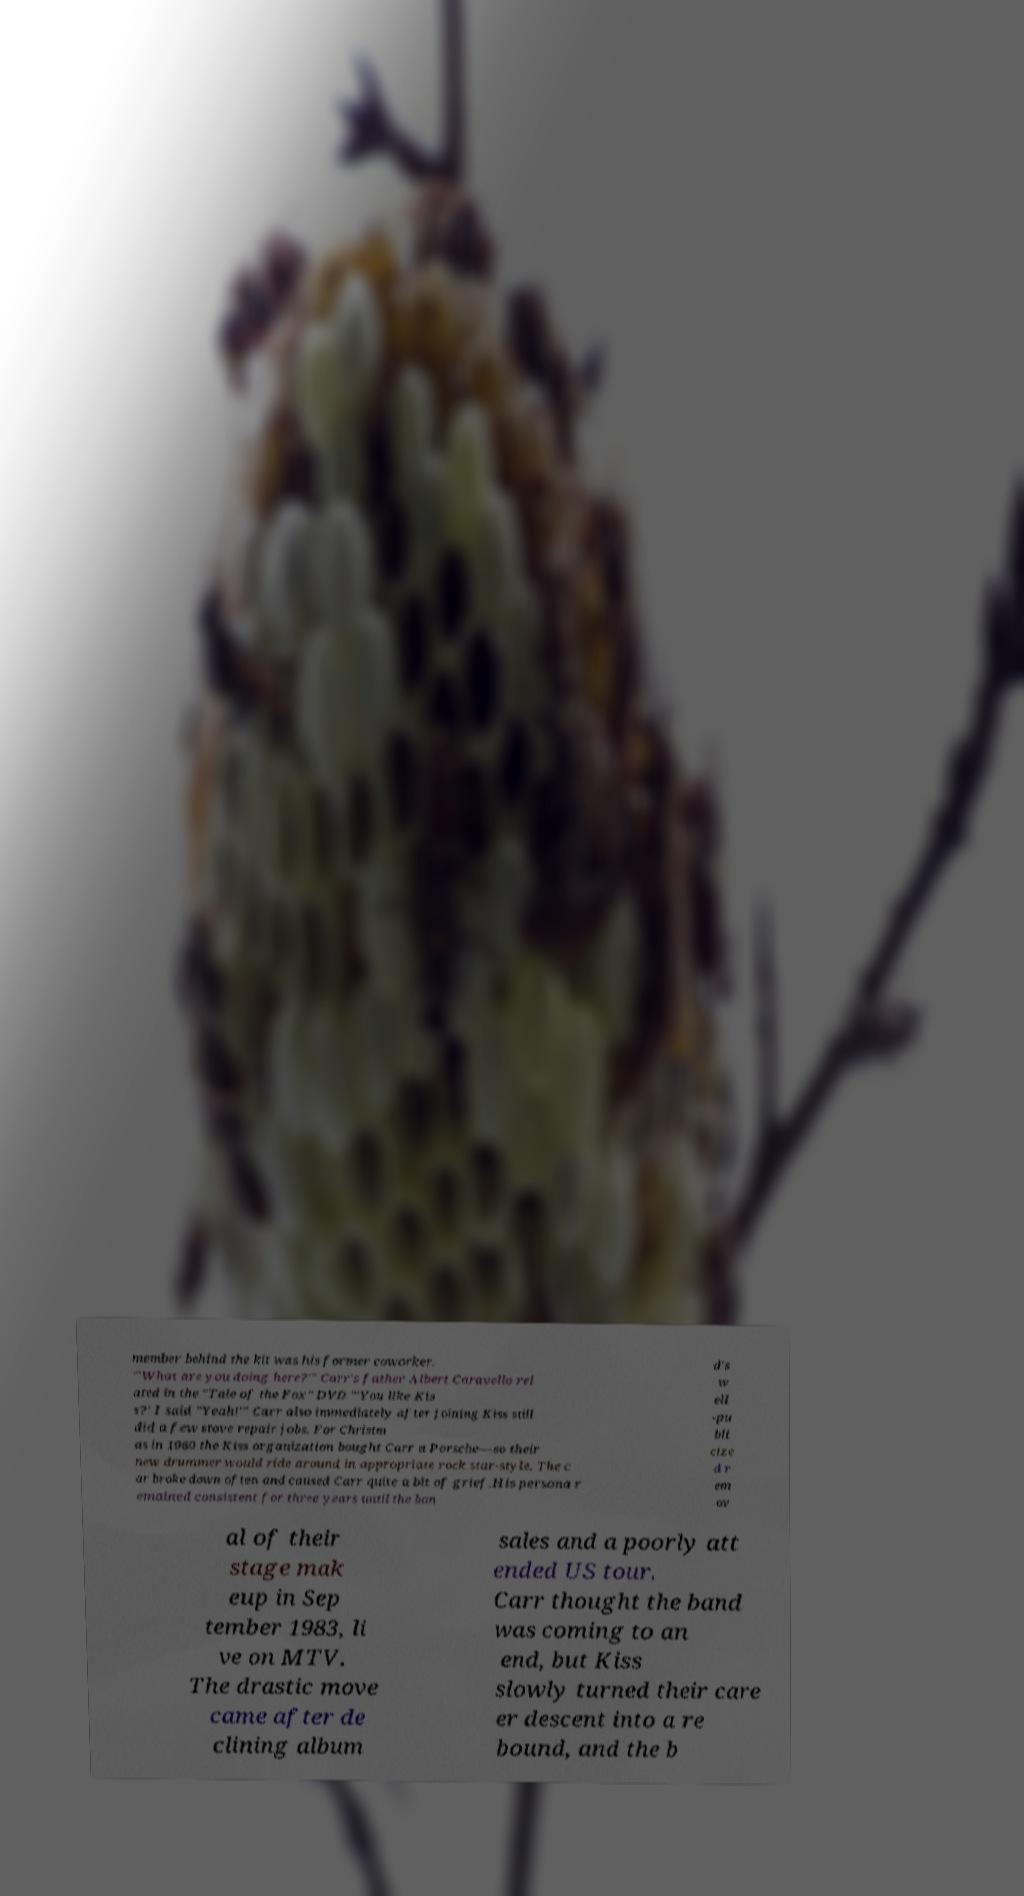For documentation purposes, I need the text within this image transcribed. Could you provide that? member behind the kit was his former coworker. "'What are you doing here?'" Carr's father Albert Caravello rel ated in the "Tale of the Fox" DVD "'You like Kis s?' I said "Yeah!'" Carr also immediately after joining Kiss still did a few stove repair jobs. For Christm as in 1980 the Kiss organization bought Carr a Porsche—so their new drummer would ride around in appropriate rock star-style. The c ar broke down often and caused Carr quite a bit of grief.His persona r emained consistent for three years until the ban d's w ell -pu bli cize d r em ov al of their stage mak eup in Sep tember 1983, li ve on MTV. The drastic move came after de clining album sales and a poorly att ended US tour. Carr thought the band was coming to an end, but Kiss slowly turned their care er descent into a re bound, and the b 